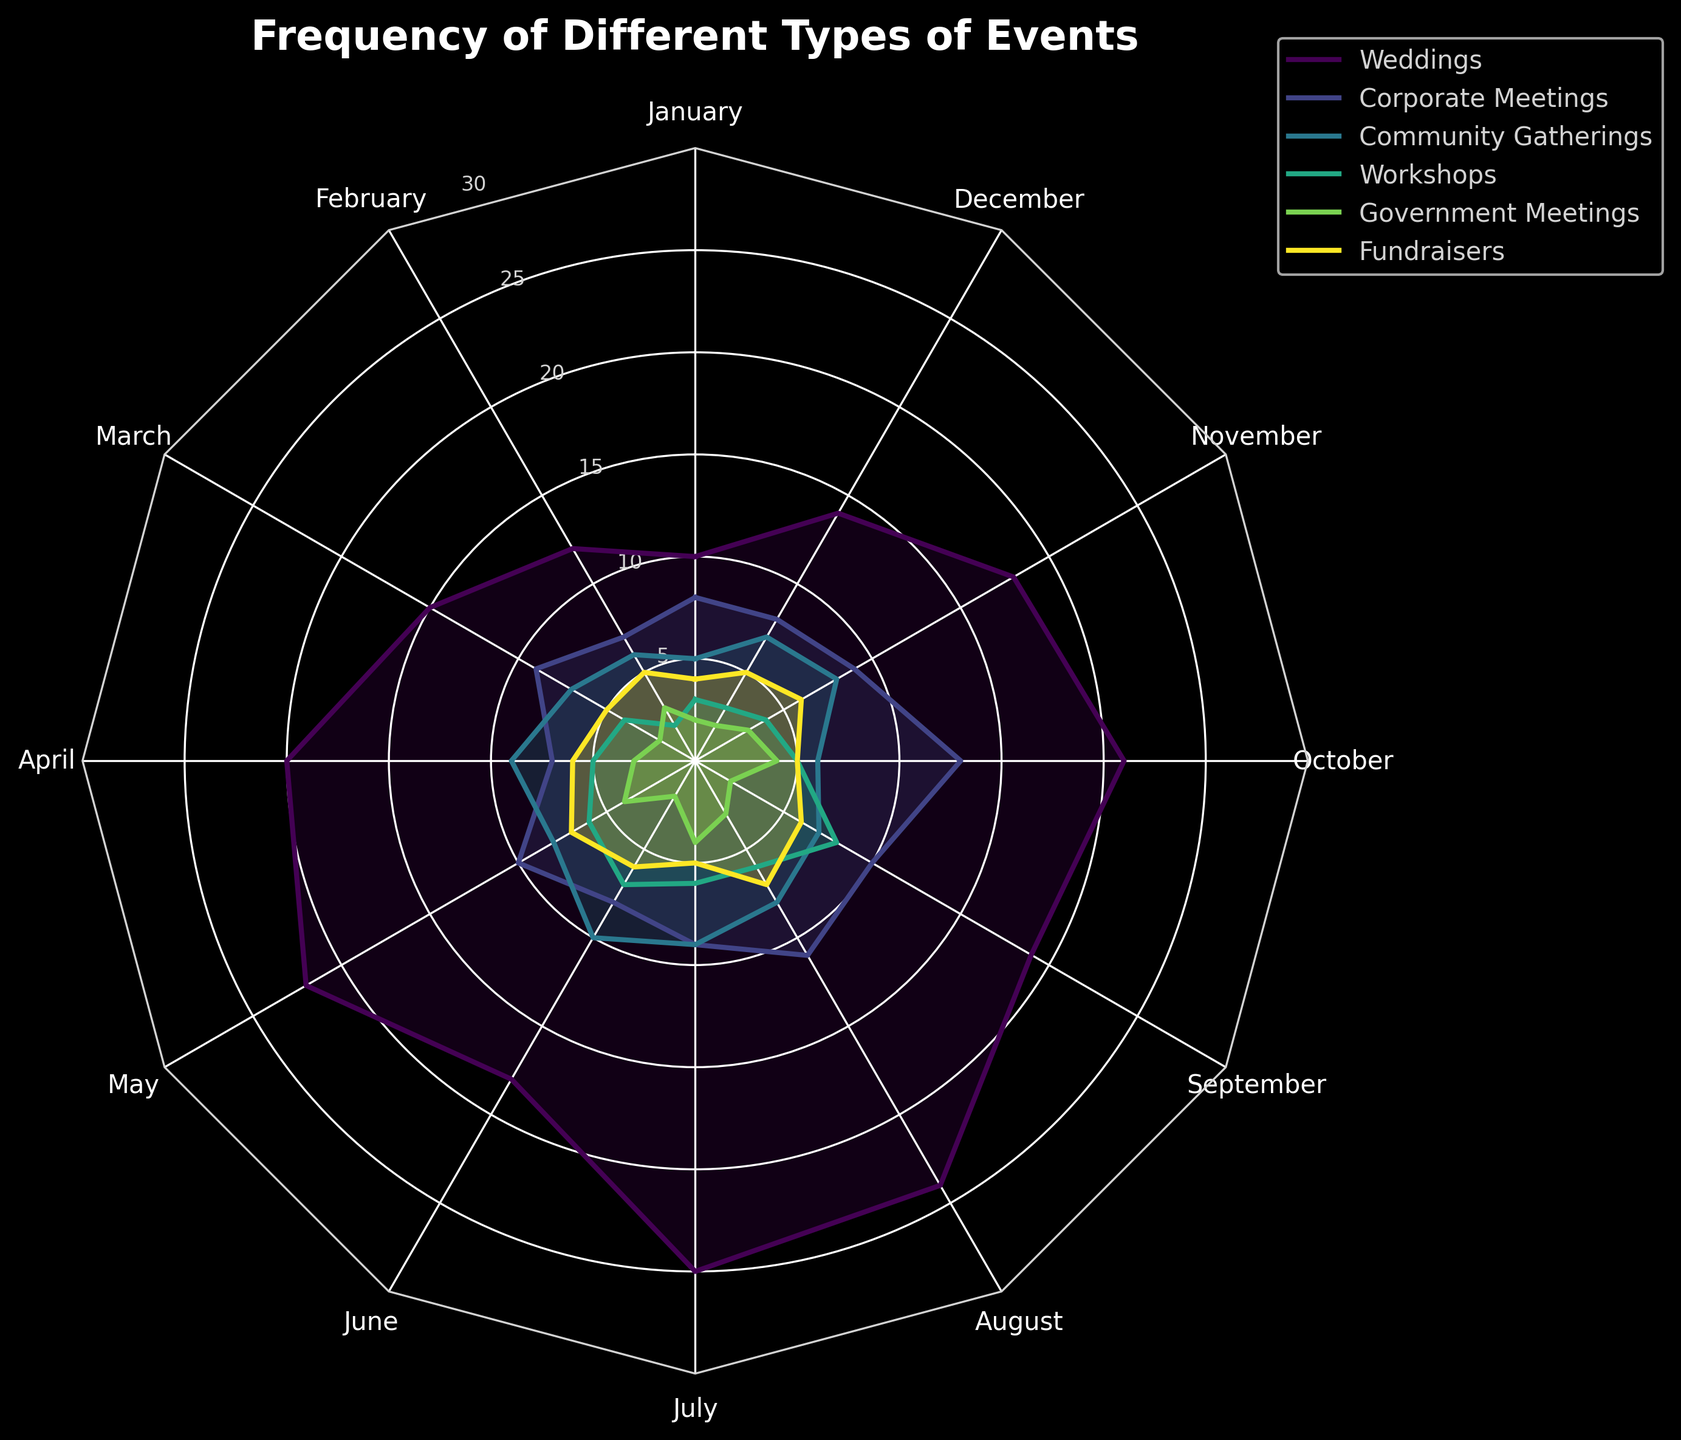What's the title of the radar chart? The title can usually be found at the top of the chart in larger font or bold text. In this case, the title is "Frequency of Different Types of Events" as stated in the code that generates the figure.
Answer: Frequency of Different Types of Events Which event type has the highest frequency in July? To determine this, look at the values for each event type in July. Weddings have the highest value in July at 25, compared to other event types which are all lower than this value.
Answer: Weddings What is the average number of corporate meetings held each month? Add the number of corporate meetings for each month and then divide by the number of months. (8+7+9+7+10+8+9+11+10+13+9+8) / 12 = 109 / 12 ≈ 9.08, rounding to 9 in this context.
Answer: 9 In which month are the number of community gatherings and fundraisers equal? Compare the values of community gatherings and fundraisers for each month and find the month where the values match. Both community gatherings and fundraisers have the same frequency in April, which is 6 events.
Answer: April How many different event types are displayed in the radar chart? Count the distinct lines or entries in the legend of the radar chart, which represent different event types. According to the given data, there are six different event types.
Answer: 6 Which two event types have the highest combined frequency in May? Add the frequency numbers for each event type for May and compare sums to find the top two. Weddings have 22 and Fundraisers have 7. Combined, they have (22 + 7) = 29.
Answer: Weddings and Fundraisers Compare the frequency of workshops in June and August. Which month has more workshops? Look at the data points for workshops in June and August. Workshops in June have a frequency of 7, while in August, they have a frequency of 6.
Answer: June What is the largest single-month frequency recorded for government meetings, and in which month does it occur? Identify the highest value for government meetings across all months. Government meetings have the highest single-month frequency of 4, which occurs in May and October.
Answer: May and October How does the frequency of community gatherings in December compare to July? Compare the values of community gatherings for December and July. In December, community gatherings have a frequency of 7, while in July, they have a frequency of 9. Thus, there are fewer community gatherings in December than in July.
Answer: Fewer in December What is the combined total of weddings and corporate meetings in March? Add the values for weddings and corporate meetings in March. For weddings, there are 15 events, and for corporate meetings, there are 9 events. Thus, the combined total is 15 + 9 = 24.
Answer: 24 